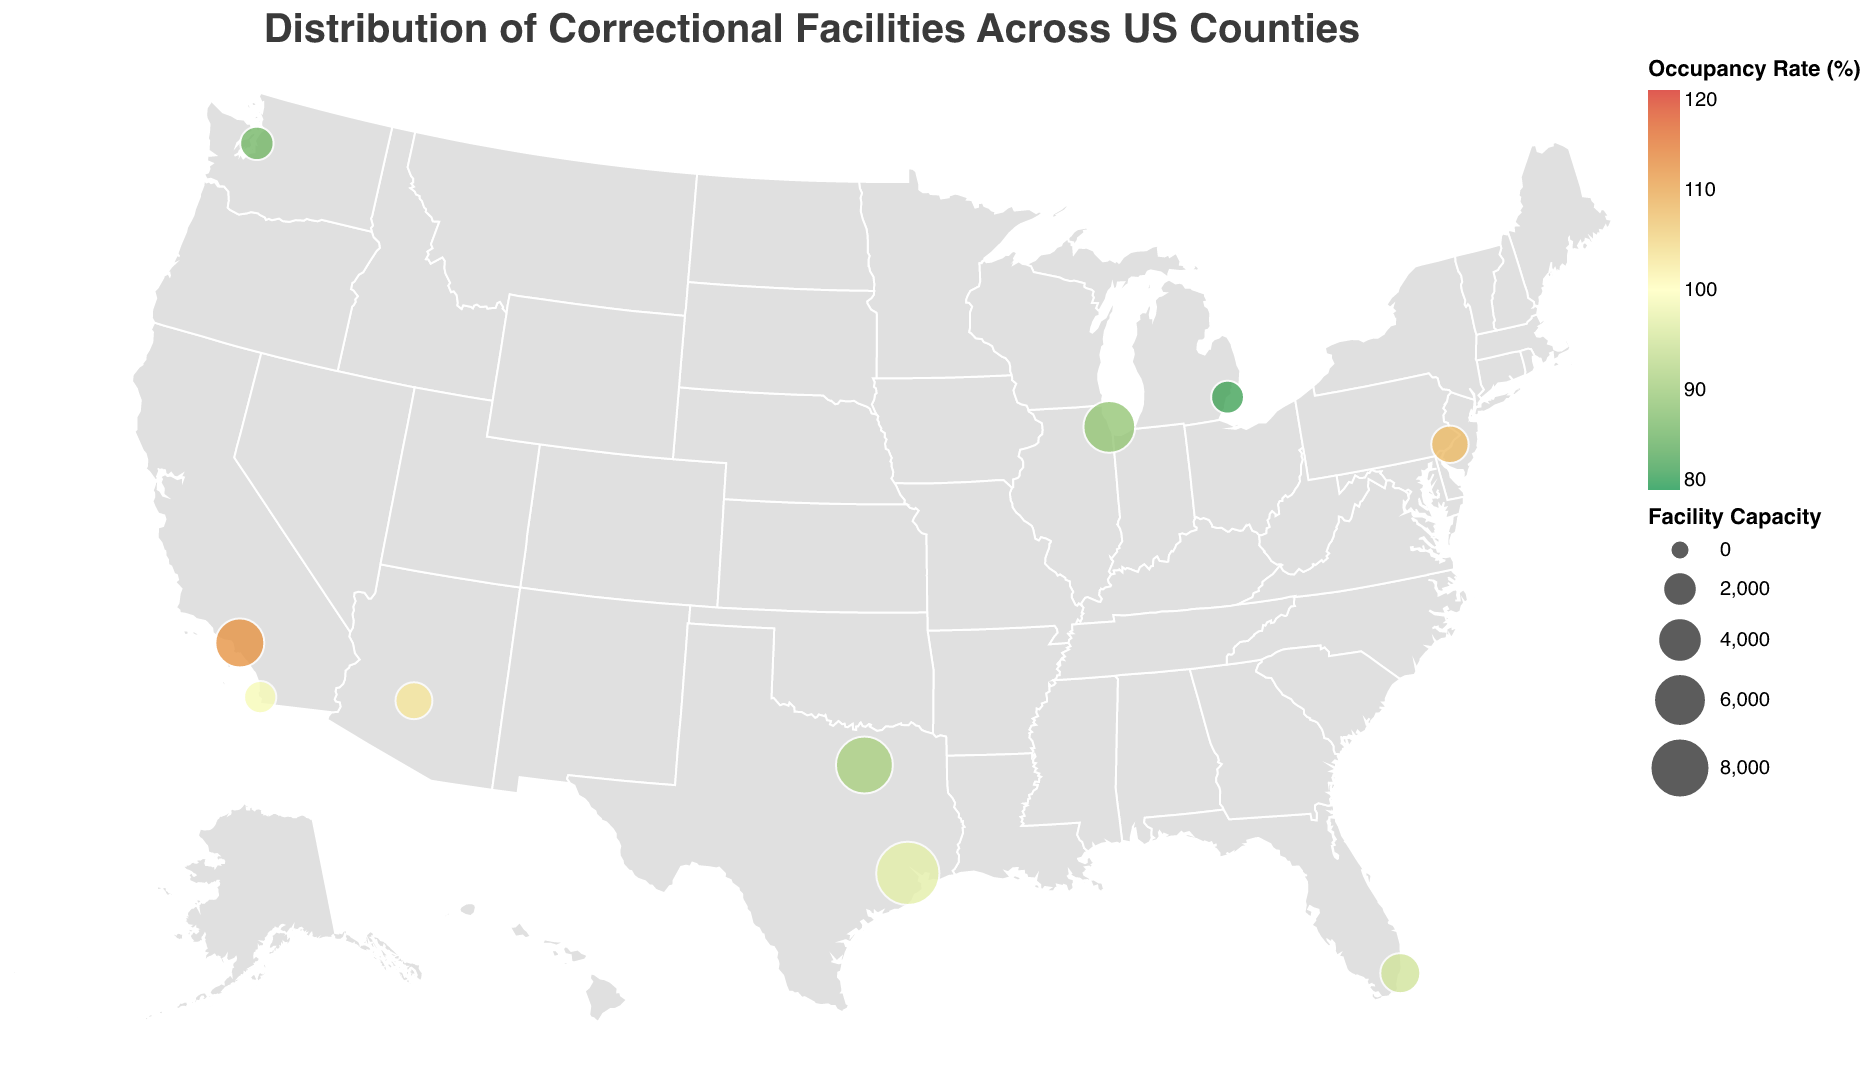What is the title of the figure? The title is displayed at the top of the figure. It generally states what the figure is showing.
Answer: Distribution of Correctional Facilities Across US Counties Which facility has the highest occupancy rate? To determine the highest occupancy rate, look for the data point with the largest numerical value under the "Occupancy Rate" category.
Answer: Men's Central Jail What is the capacity of Harris County Jail? Find Harris County Jail in the data and check the corresponding "Capacity" value.
Answer: 9000 How many correctional facilities are shown in Texas? Count the number of data points in Texas listed within the data provided.
Answer: 2 Which correctional facility in California has a higher occupancy rate? Compare the occupancy rates for the facilities listed in California: Men's Central Jail and George Bailey Detention Facility.
Answer: Men's Central Jail Which state has the most correctional facilities listed on the plot? Count the number of correctional facilities per state and identify the state with the highest count.
Answer: California What’s the average occupancy rate of the facilities in the data? Add up all the occupancy rates and divide by the total number of facilities (10). The sum is (112+89+97+103+95+86+108+91+99+82) = 962, so the average is 962/10 = 96.2.
Answer: 96.2 Which facility has the smallest capacity? Identify the data point with the lowest "Capacity" value.
Answer: King County Correctional Facility Between Men's Central Jail and Lew Sterrett Justice Center, which has a higher percentage of overcapacity? First, calculate the overcapacity percentage for each facility. For Men's Central Jail: (112 - 100) = 12%. For Lew Sterrett Justice Center: (91 - 100) = -9%. Compare these values.
Answer: Men's Central Jail Identify one correctional facility with an occupancy rate below 90%. Look through each facility’s occupancy rate and identify one that is below 90%.
Answer: King County Correctional Facility 